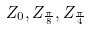<formula> <loc_0><loc_0><loc_500><loc_500>Z _ { 0 } , Z _ { \frac { \pi } { 8 } } , Z _ { \frac { \pi } { 4 } }</formula> 